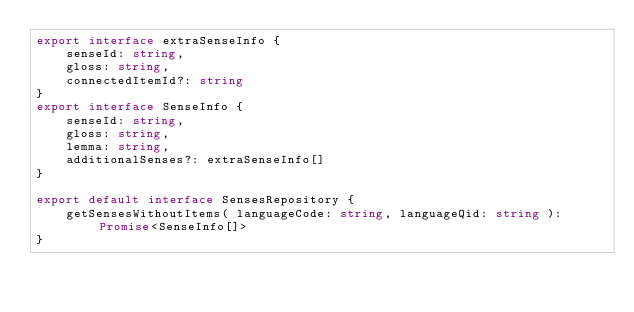<code> <loc_0><loc_0><loc_500><loc_500><_TypeScript_>export interface extraSenseInfo {
	senseId: string,
	gloss: string,
	connectedItemId?: string
}
export interface SenseInfo {
	senseId: string,
	gloss: string,
	lemma: string,
	additionalSenses?: extraSenseInfo[]
}

export default interface SensesRepository {
	getSensesWithoutItems( languageCode: string, languageQid: string ): Promise<SenseInfo[]>
}
</code> 